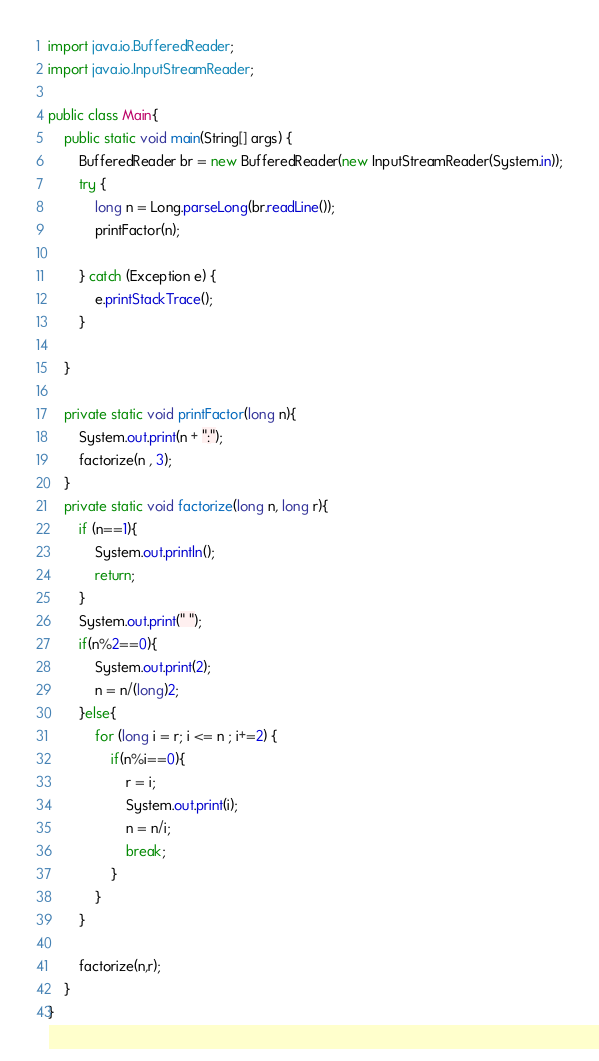Convert code to text. <code><loc_0><loc_0><loc_500><loc_500><_Java_>import java.io.BufferedReader;
import java.io.InputStreamReader;

public class Main{
    public static void main(String[] args) {
        BufferedReader br = new BufferedReader(new InputStreamReader(System.in));
        try {
            long n = Long.parseLong(br.readLine());
            printFactor(n);

        } catch (Exception e) {
            e.printStackTrace();
        }

    }

    private static void printFactor(long n){
        System.out.print(n + ":");
        factorize(n , 3);
    }
    private static void factorize(long n, long r){
        if (n==1){
            System.out.println();
            return;
        }
        System.out.print(" ");
        if(n%2==0){
            System.out.print(2);
            n = n/(long)2;
        }else{
            for (long i = r; i <= n ; i+=2) {
                if(n%i==0){
                    r = i;
                    System.out.print(i);
                    n = n/i;
                    break;
                }
            }
        }

        factorize(n,r);
    }
}</code> 